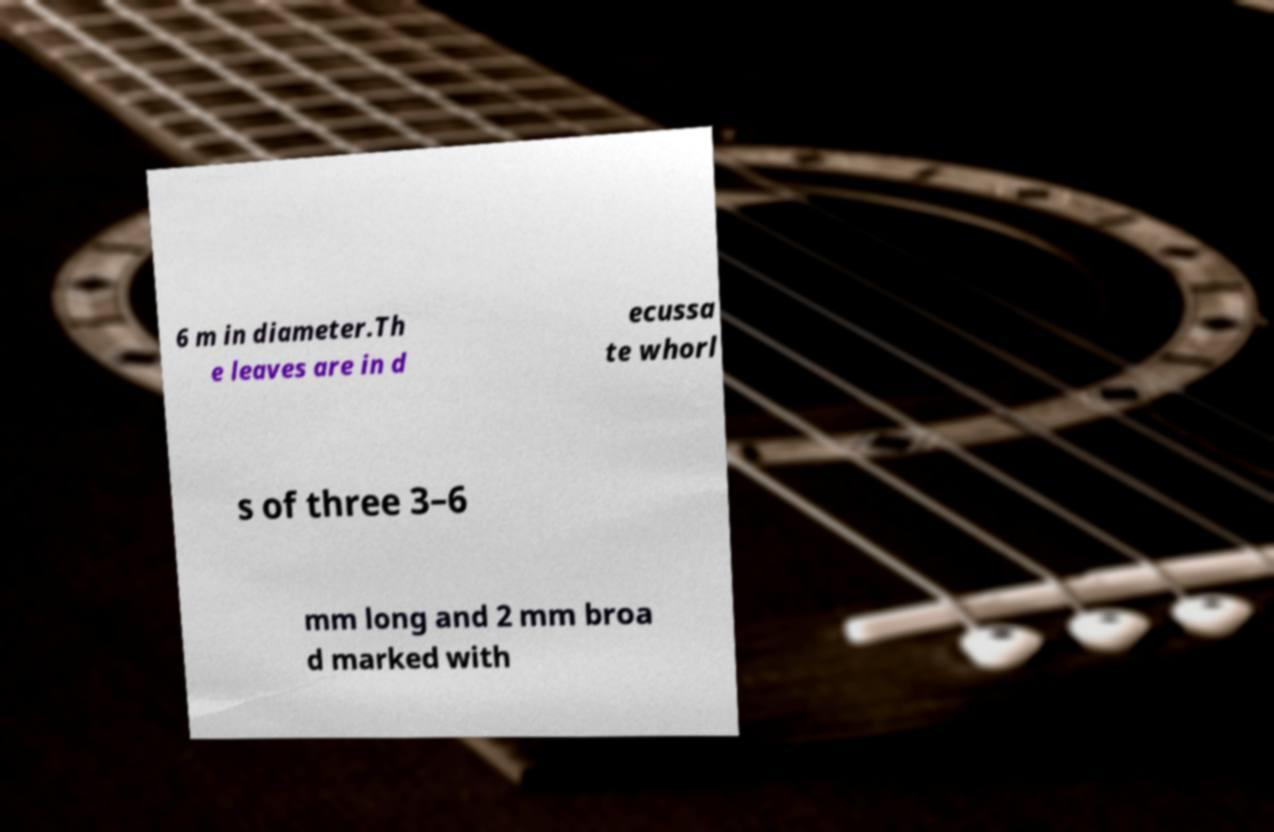Please identify and transcribe the text found in this image. 6 m in diameter.Th e leaves are in d ecussa te whorl s of three 3–6 mm long and 2 mm broa d marked with 